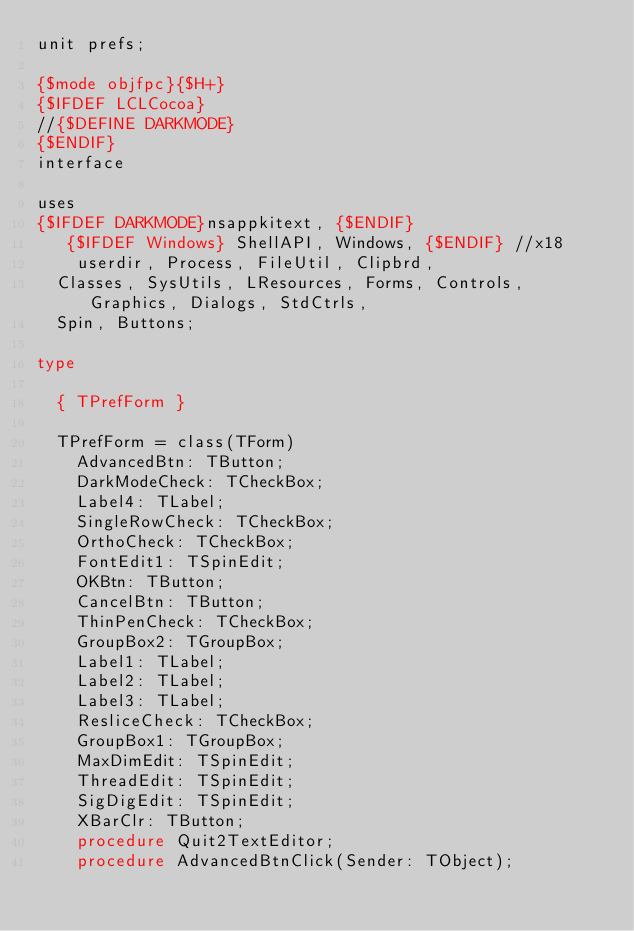<code> <loc_0><loc_0><loc_500><loc_500><_Pascal_>unit prefs;

{$mode objfpc}{$H+}
{$IFDEF LCLCocoa}
//{$DEFINE DARKMODE}
{$ENDIF}
interface

uses
{$IFDEF DARKMODE}nsappkitext, {$ENDIF}
   {$IFDEF Windows} ShellAPI, Windows, {$ENDIF} //x18
    userdir, Process, FileUtil, Clipbrd,
  Classes, SysUtils, LResources, Forms, Controls, Graphics, Dialogs, StdCtrls,
  Spin, Buttons;

type

  { TPrefForm }

  TPrefForm = class(TForm)
    AdvancedBtn: TButton;
    DarkModeCheck: TCheckBox;
    Label4: TLabel;
    SingleRowCheck: TCheckBox;
    OrthoCheck: TCheckBox;
    FontEdit1: TSpinEdit;
    OKBtn: TButton;
    CancelBtn: TButton;
    ThinPenCheck: TCheckBox;
    GroupBox2: TGroupBox;
    Label1: TLabel;
    Label2: TLabel;
    Label3: TLabel;
    ResliceCheck: TCheckBox;
    GroupBox1: TGroupBox;
    MaxDimEdit: TSpinEdit;
    ThreadEdit: TSpinEdit;
    SigDigEdit: TSpinEdit;
    XBarClr: TButton;
    procedure Quit2TextEditor;
    procedure AdvancedBtnClick(Sender: TObject);</code> 